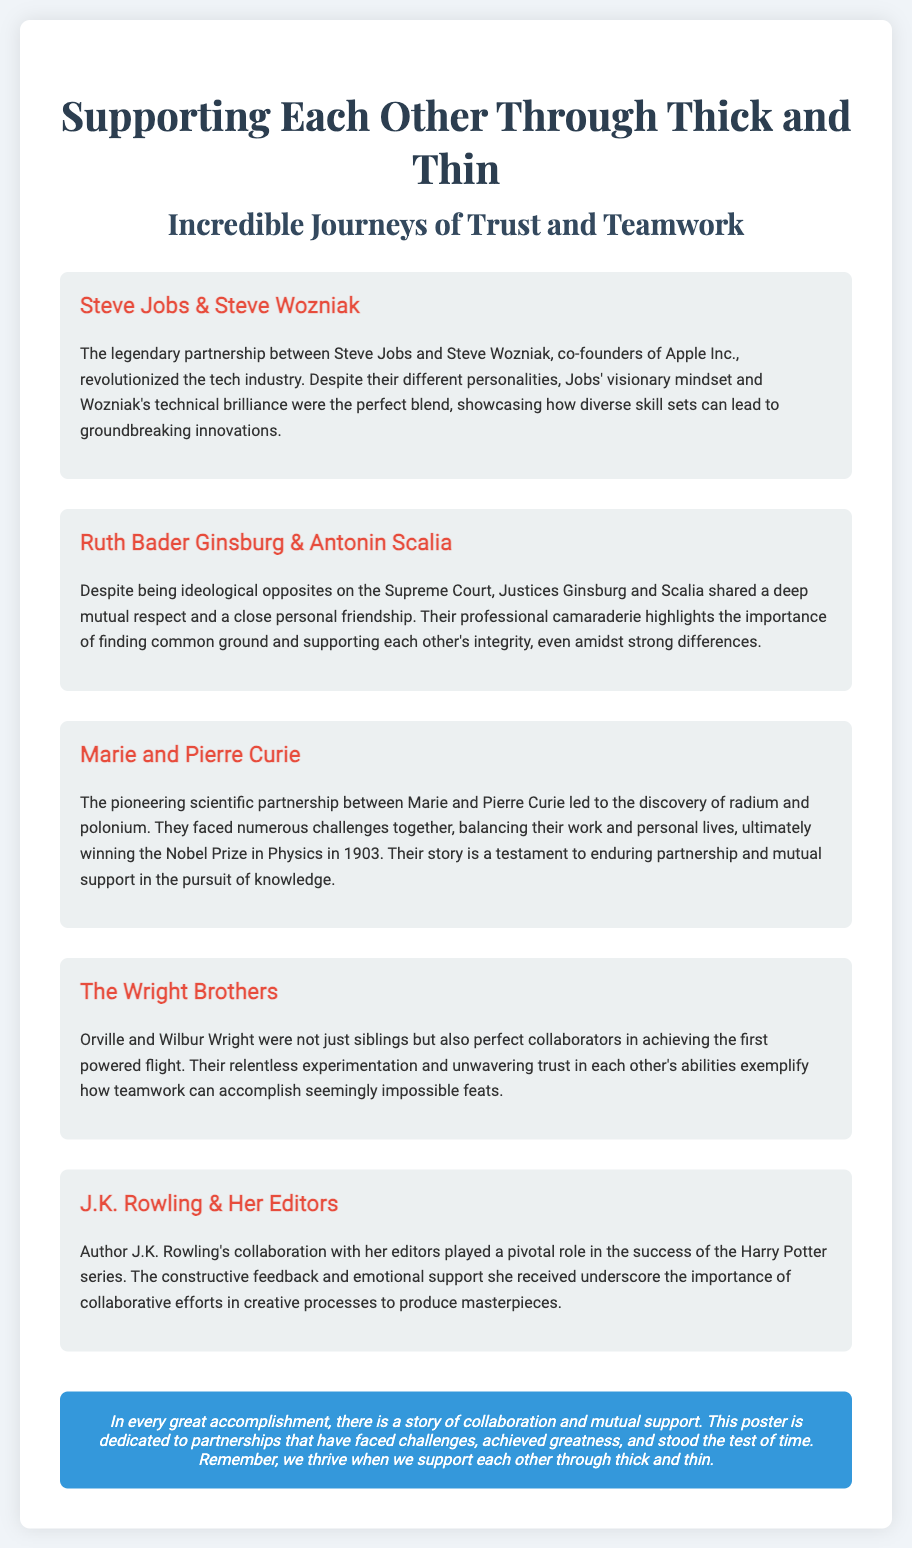What is the title of the poster? The title of the poster is prominently displayed at the top, indicating the main theme of the content.
Answer: Supporting Each Other Through Thick and Thin Who are the co-founders of Apple Inc.? The document highlights a legendary partnership between two individuals who are known for founding a major technology company.
Answer: Steve Jobs & Steve Wozniak Which two justices are noted for their mutual respect despite ideological differences? These individuals are recognized for their unique friendship on the Supreme Court, despite contrasting viewpoints.
Answer: Ruth Bader Ginsburg & Antonin Scalia What scientific discovery did Marie and Pierre Curie make? The text details their collaborative efforts in the field of science, leading to important findings.
Answer: Radium and polonium What did J.K. Rowling's collaboration with her editors emphasize? The passage discusses the significant role of constructive feedback and support in a well-known author's success.
Answer: Importance of collaborative efforts How did the Wright Brothers exemplify teamwork? The document describes how these brothers worked together toward a groundbreaking achievement in aviation.
Answer: Relentless experimentation and unwavering trust In what year did Marie and Pierre Curie win the Nobel Prize in Physics? Their accomplishment is detailed as part of their scientific achievements, including this notable award.
Answer: 1903 What is the overall message of the poster? The conclusion emphasizes a key principle shared in the document regarding collaboration and support.
Answer: We thrive when we support each other through thick and thin 